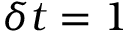<formula> <loc_0><loc_0><loc_500><loc_500>\delta t = 1</formula> 